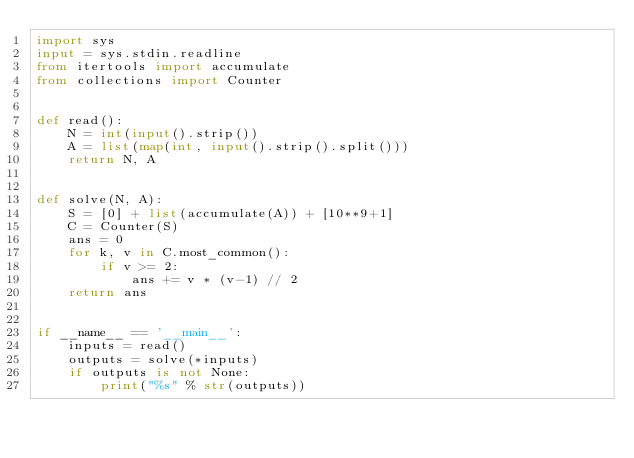Convert code to text. <code><loc_0><loc_0><loc_500><loc_500><_Python_>import sys
input = sys.stdin.readline
from itertools import accumulate
from collections import Counter


def read():
    N = int(input().strip())
    A = list(map(int, input().strip().split()))
    return N, A


def solve(N, A):
    S = [0] + list(accumulate(A)) + [10**9+1]
    C = Counter(S)
    ans = 0
    for k, v in C.most_common():
        if v >= 2:
            ans += v * (v-1) // 2
    return ans


if __name__ == '__main__':
    inputs = read()
    outputs = solve(*inputs)
    if outputs is not None:
        print("%s" % str(outputs))
</code> 